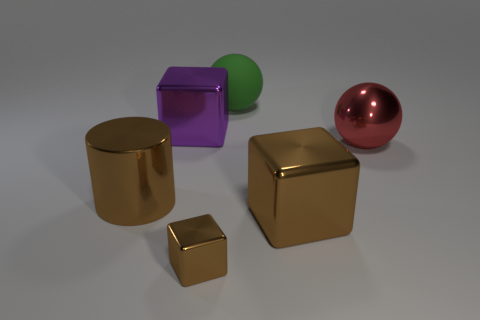How many other things are there of the same material as the purple cube?
Offer a terse response. 4. How many objects are the same color as the cylinder?
Give a very brief answer. 2. There is a brown object to the right of the brown metal thing in front of the brown cube that is to the right of the green object; how big is it?
Your answer should be compact. Large. What number of rubber things are either spheres or large things?
Provide a short and direct response. 1. There is a big green thing; does it have the same shape as the object left of the large purple metallic block?
Your response must be concise. No. Are there more red things left of the metallic ball than matte things left of the large purple block?
Provide a short and direct response. No. Is there anything else that is the same color as the shiny sphere?
Your answer should be compact. No. Is there a tiny block on the right side of the ball that is on the left side of the big brown metal object that is on the right side of the purple cube?
Provide a short and direct response. No. There is a large thing that is on the left side of the purple metal thing; is it the same shape as the purple shiny thing?
Your response must be concise. No. Is the number of large green things to the left of the purple object less than the number of large purple cubes in front of the tiny brown thing?
Keep it short and to the point. No. 